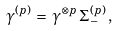Convert formula to latex. <formula><loc_0><loc_0><loc_500><loc_500>\gamma ^ { ( p ) } \, = \, \gamma ^ { \otimes p } \, \Sigma _ { - } ^ { ( p ) } \, ,</formula> 